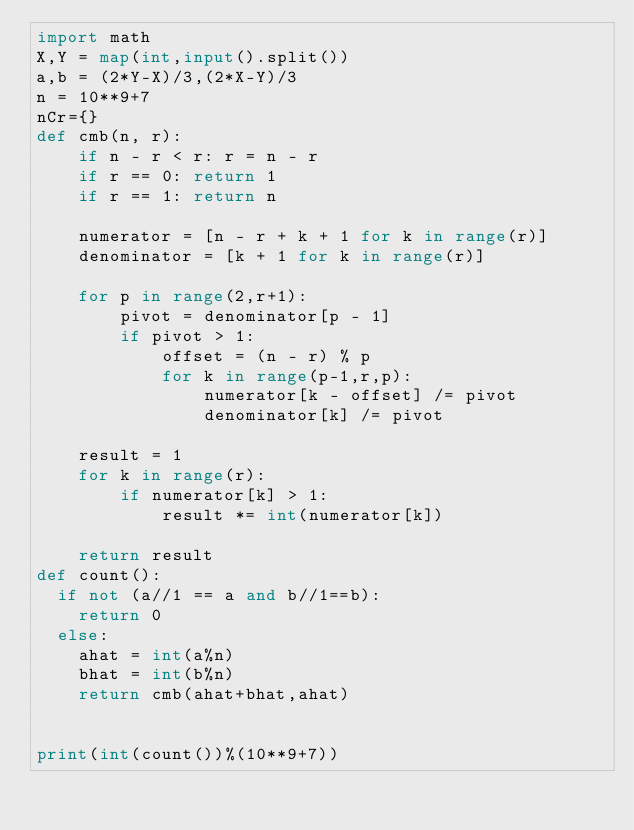Convert code to text. <code><loc_0><loc_0><loc_500><loc_500><_Python_>import math
X,Y = map(int,input().split())
a,b = (2*Y-X)/3,(2*X-Y)/3
n = 10**9+7
nCr={}
def cmb(n, r):
    if n - r < r: r = n - r
    if r == 0: return 1
    if r == 1: return n

    numerator = [n - r + k + 1 for k in range(r)]
    denominator = [k + 1 for k in range(r)]

    for p in range(2,r+1):
        pivot = denominator[p - 1]
        if pivot > 1:
            offset = (n - r) % p
            for k in range(p-1,r,p):
                numerator[k - offset] /= pivot
                denominator[k] /= pivot

    result = 1
    for k in range(r):
        if numerator[k] > 1:
            result *= int(numerator[k])

    return result
def count():
  if not (a//1 == a and b//1==b):
    return 0
  else:
    ahat = int(a%n)
    bhat = int(b%n)
    return cmb(ahat+bhat,ahat)


print(int(count())%(10**9+7))</code> 